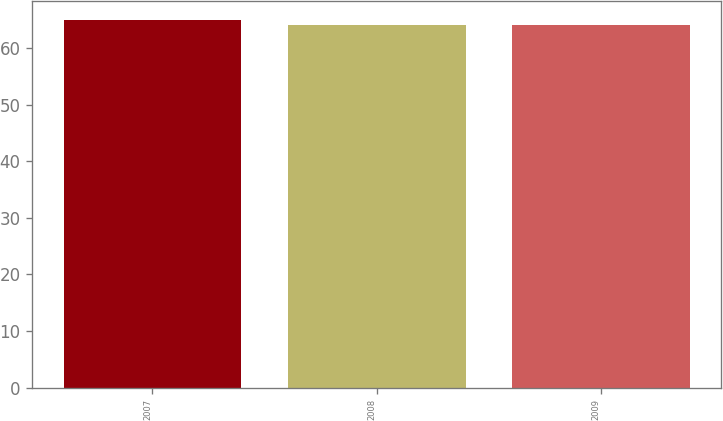Convert chart. <chart><loc_0><loc_0><loc_500><loc_500><bar_chart><fcel>2007<fcel>2008<fcel>2009<nl><fcel>65<fcel>64<fcel>64.1<nl></chart> 